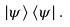Convert formula to latex. <formula><loc_0><loc_0><loc_500><loc_500>| \psi \rangle \, \langle \psi | \, .</formula> 